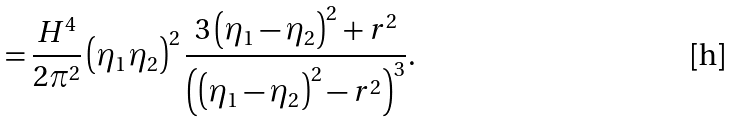<formula> <loc_0><loc_0><loc_500><loc_500>= \frac { H ^ { 4 } } { 2 \pi ^ { 2 } } \left ( \eta _ { 1 } \eta _ { 2 } \right ) ^ { 2 } \frac { 3 \left ( \eta _ { 1 } - \eta _ { 2 } \right ) ^ { 2 } + r ^ { 2 } } { \left ( \left ( \eta _ { 1 } - \eta _ { 2 } \right ) ^ { 2 } - r ^ { 2 } \right ) ^ { 3 } } .</formula> 